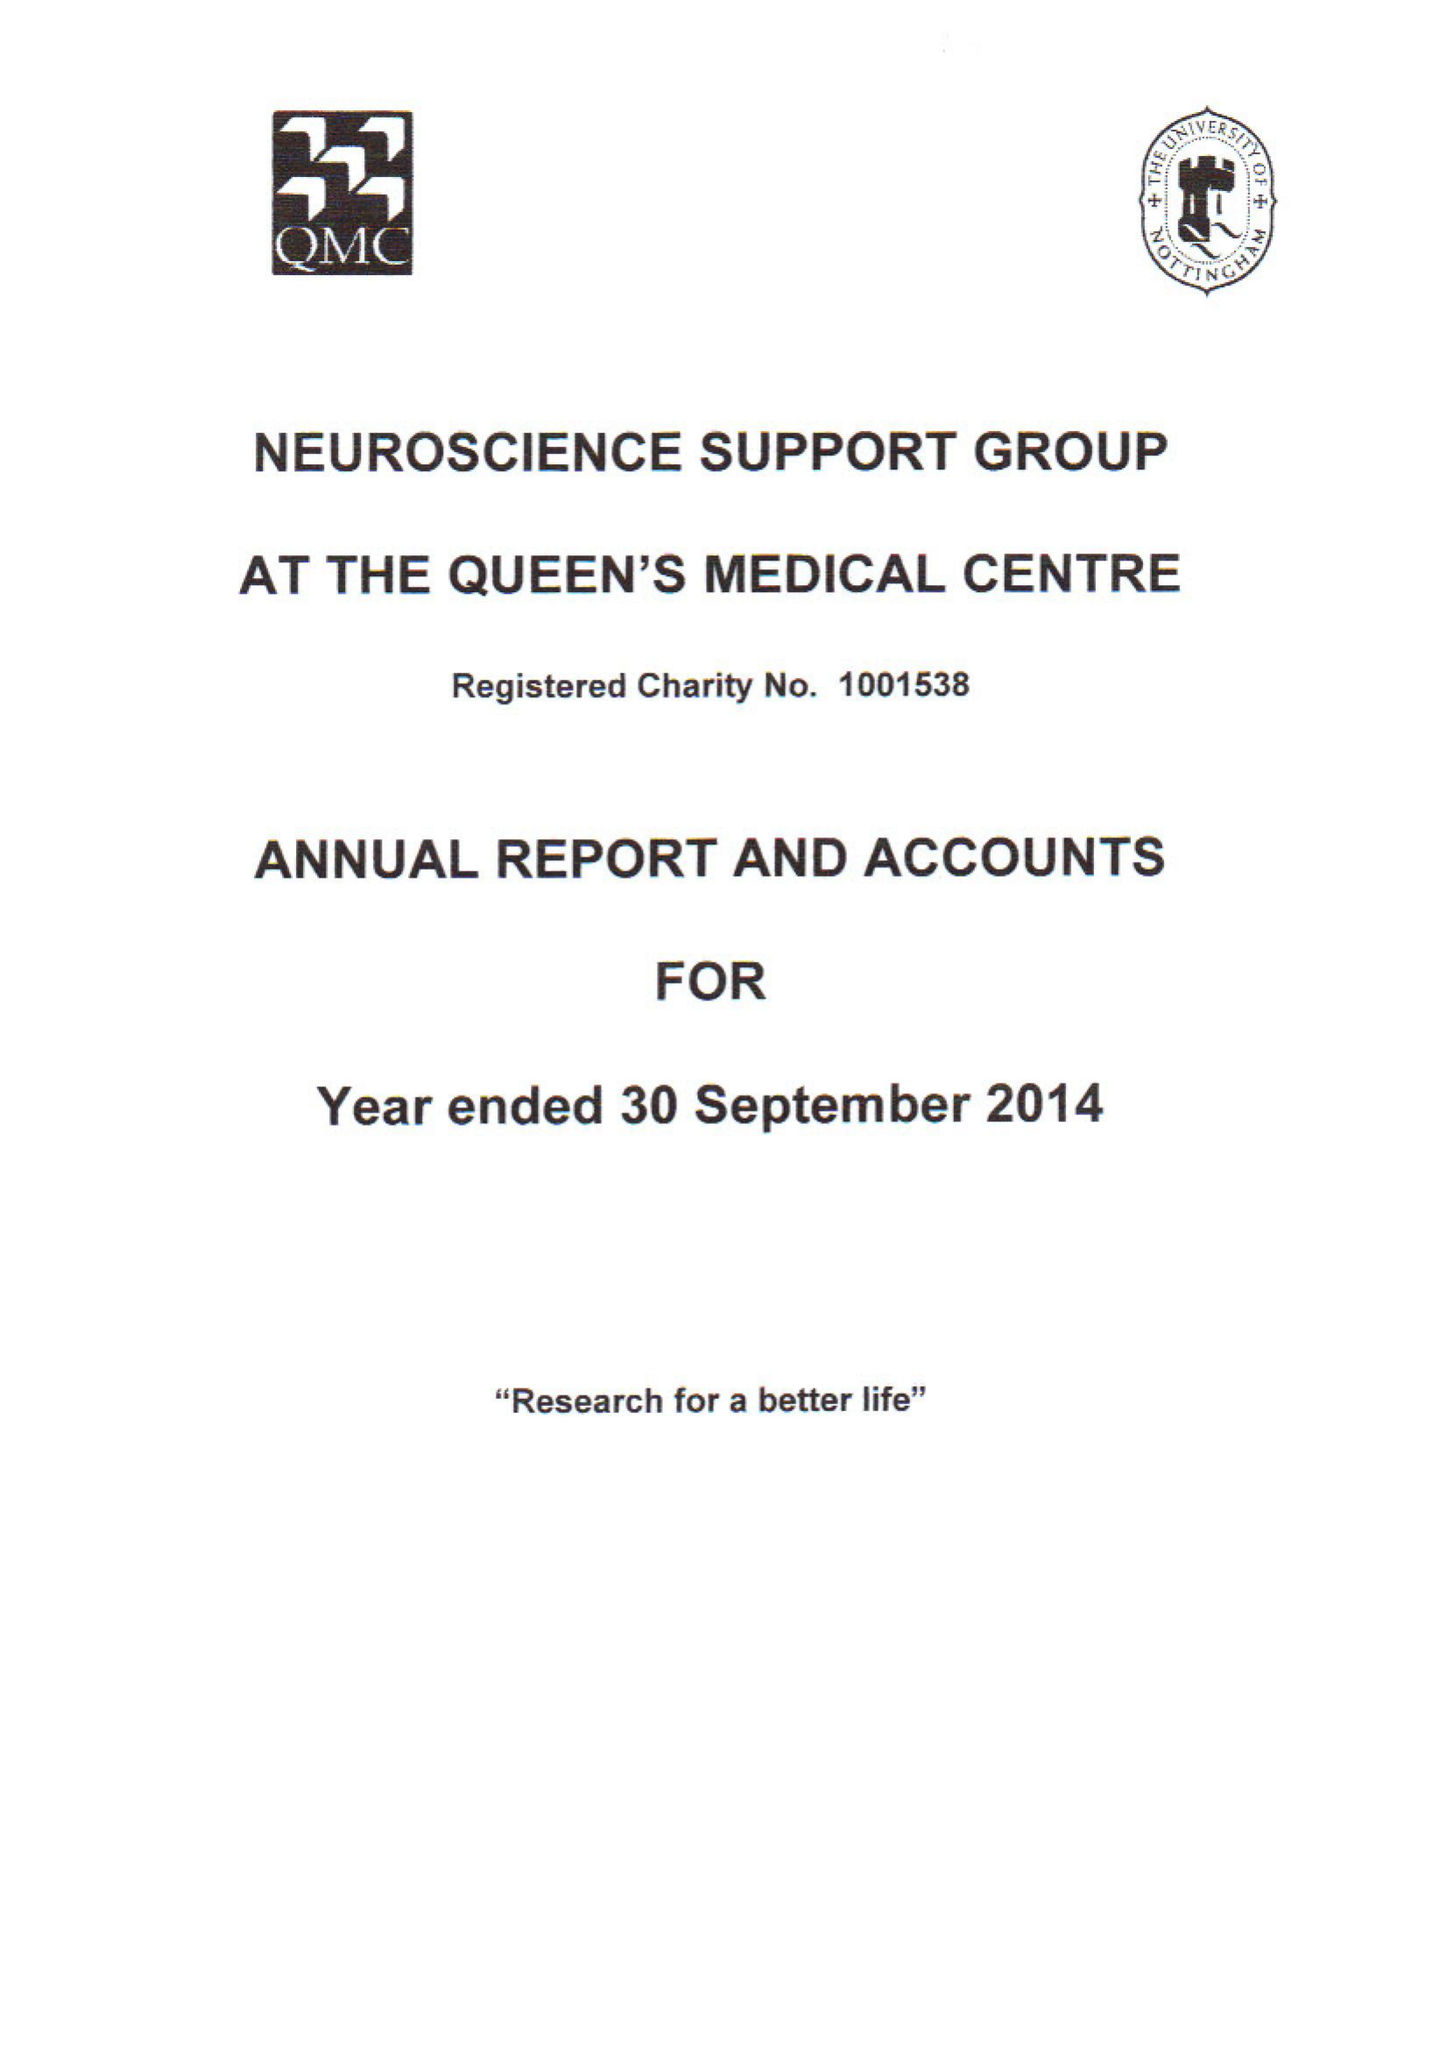What is the value for the charity_name?
Answer the question using a single word or phrase. The Neuroscience Support Group At The Queens Medical Centre 